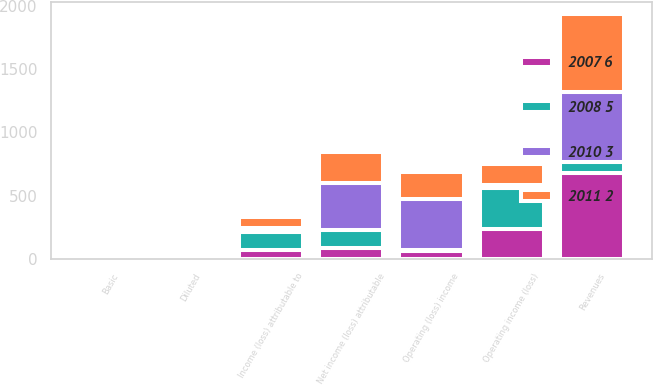Convert chart to OTSL. <chart><loc_0><loc_0><loc_500><loc_500><stacked_bar_chart><ecel><fcel>Revenues<fcel>Operating income (loss)<fcel>Income (loss) attributable to<fcel>Basic<fcel>Diluted<fcel>Operating (loss) income<fcel>Net income (loss) attributable<nl><fcel>2008 5<fcel>81<fcel>329<fcel>139<fcel>0.84<fcel>0.83<fcel>4<fcel>143<nl><fcel>2007 6<fcel>681<fcel>232<fcel>70<fcel>0.39<fcel>0.39<fcel>64<fcel>81<nl><fcel>2011 2<fcel>616<fcel>160<fcel>92<fcel>0.48<fcel>0.48<fcel>216<fcel>246<nl><fcel>2010 3<fcel>559<fcel>26<fcel>32<fcel>0.16<fcel>0.16<fcel>405<fcel>374<nl></chart> 